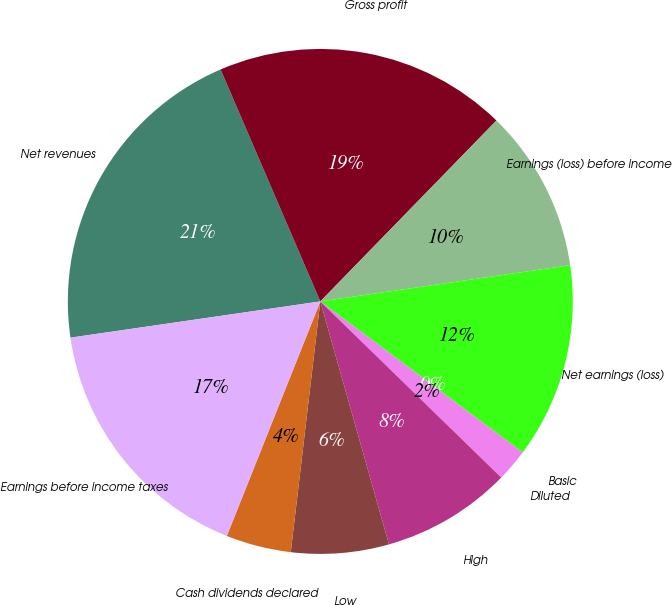<chart> <loc_0><loc_0><loc_500><loc_500><pie_chart><fcel>Net revenues<fcel>Gross profit<fcel>Earnings (loss) before income<fcel>Net earnings (loss)<fcel>Basic<fcel>Diluted<fcel>High<fcel>Low<fcel>Cash dividends declared<fcel>Earnings before income taxes<nl><fcel>20.83%<fcel>18.75%<fcel>10.42%<fcel>12.5%<fcel>0.0%<fcel>2.08%<fcel>8.33%<fcel>6.25%<fcel>4.17%<fcel>16.67%<nl></chart> 